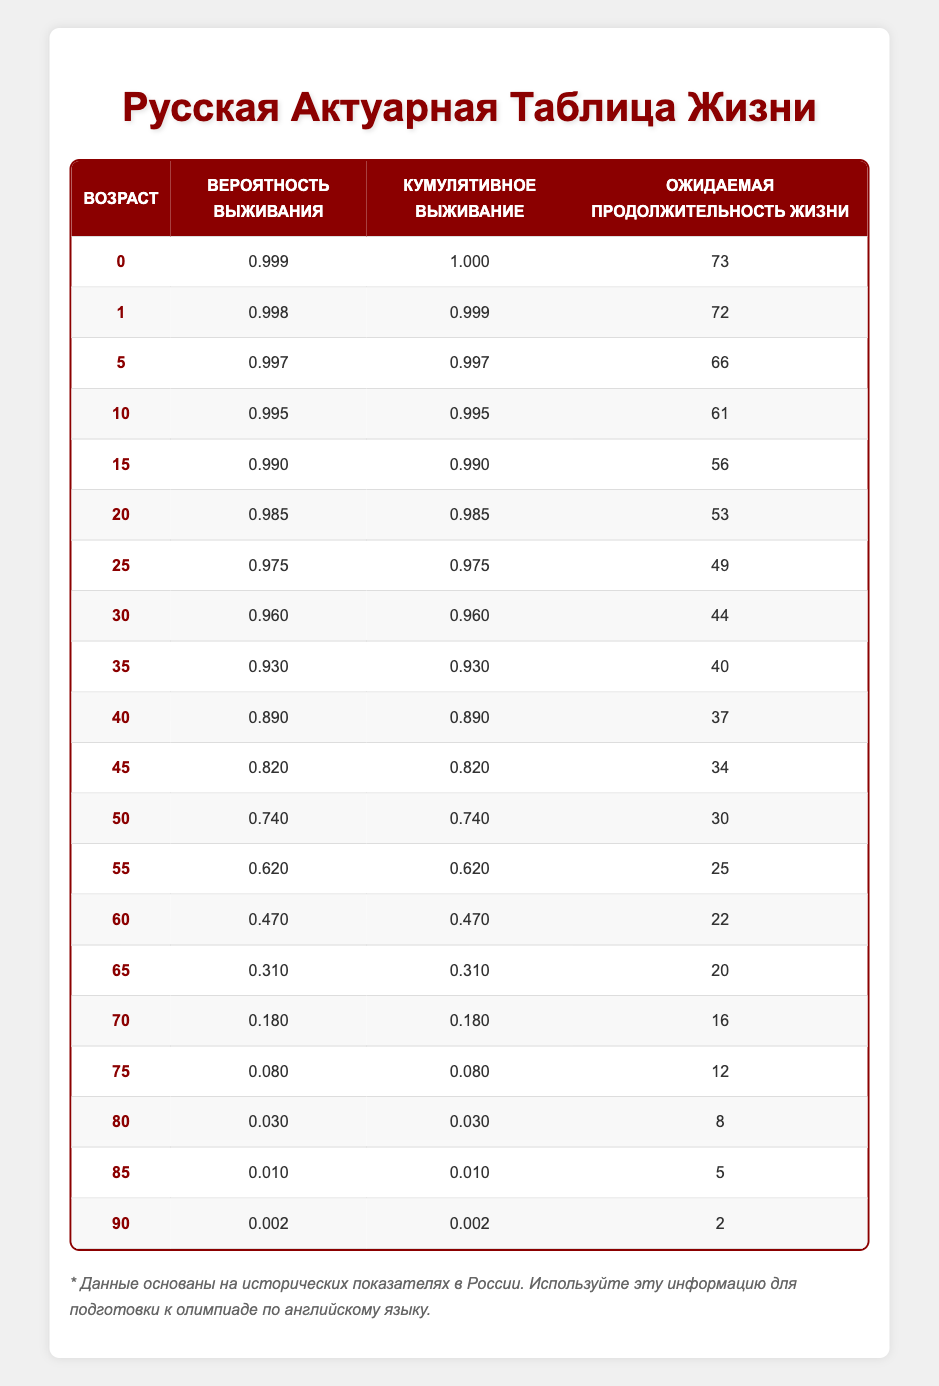What is the probability of survival for a 50-year-old? The table shows the "Вероятность выживания" for the age of 50, which is 0.740.
Answer: 0.740 At what age does the probability of survival drop below 0.100? Looking through the "Вероятность выживания" column, the values drop below 0.100 starting at age 85, where the probability is 0.010.
Answer: 85 What is the cumulative survival probability for a 10-year-old? The cumulative survival probability for a 10-year-old can be found in the table as 0.995.
Answer: 0.995 How much has the life expectancy decreased from age 20 to age 50? The life expectancy at age 20 is 53, and at age 50 it is 30. The decrease is 53 - 30 = 23 years.
Answer: 23 Is the probability of survival higher for a 25-year-old compared to a 70-year-old? Checking the values in the table, the probability for a 25-year-old is 0.975, and for a 70-year-old, it is 0.180, which confirms that the 25-year-old has a higher survival probability.
Answer: Yes If a person survives to age 60, what is their probability of survival until age 70? The table shows the probability of a 60-year-old surviving to age 70 is 0.180, meaning their chance of reaching that age is relatively low compared to their age.
Answer: 0.180 What is the median life expectancy for the age group 0 to 50? The ages from 0 to 50 consist of 11 values. To find the median, list them out: (73, 72, 66, 61, 56, 53, 49, 44, 40, 37, 34) and the middle value is 56 because it’s the 6th value in an ordered list of 11 numbers.
Answer: 56 What is the average life expectancy of people aged 40 to 90? First, we take the life expectancies from ages 40 to 90: 37, 34, 30, 25, 22, 20, 16, 12, 8, 5, 2. Summing these values gives 37 + 34 + 30 + 25 + 22 + 20 + 16 + 12 + 8 + 5 + 2 =  264. There are 11 age entries, so average life expectancy = 264 / 11 ≈ 24. Hence, the average is approximately 24 years.
Answer: 24 At what age does the expected lifespan reach below 10 years? The table shows that this happens at age 80 where the life expectancy drops to 8 years.
Answer: 80 